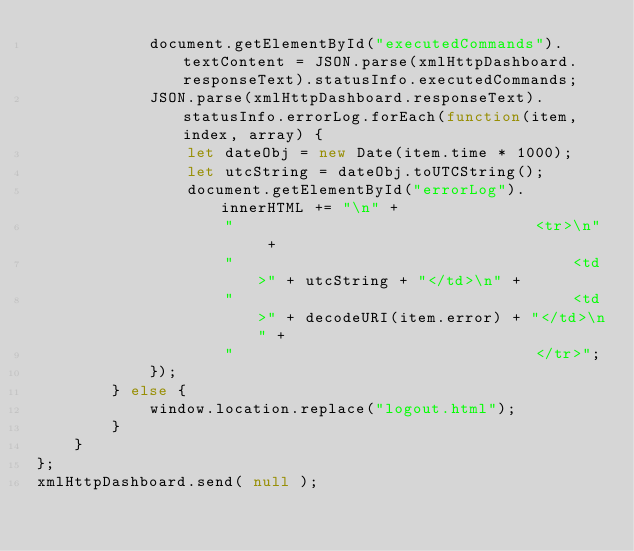Convert code to text. <code><loc_0><loc_0><loc_500><loc_500><_JavaScript_>            document.getElementById("executedCommands").textContent = JSON.parse(xmlHttpDashboard.responseText).statusInfo.executedCommands;
            JSON.parse(xmlHttpDashboard.responseText).statusInfo.errorLog.forEach(function(item, index, array) {
                let dateObj = new Date(item.time * 1000);
                let utcString = dateObj.toUTCString();
                document.getElementById("errorLog").innerHTML += "\n" +
                    "                                <tr>\n" +
                    "                                    <td>" + utcString + "</td>\n" +
                    "                                    <td>" + decodeURI(item.error) + "</td>\n" +
                    "                                </tr>";
            });
        } else {
            window.location.replace("logout.html");
        }
    }
};
xmlHttpDashboard.send( null );</code> 